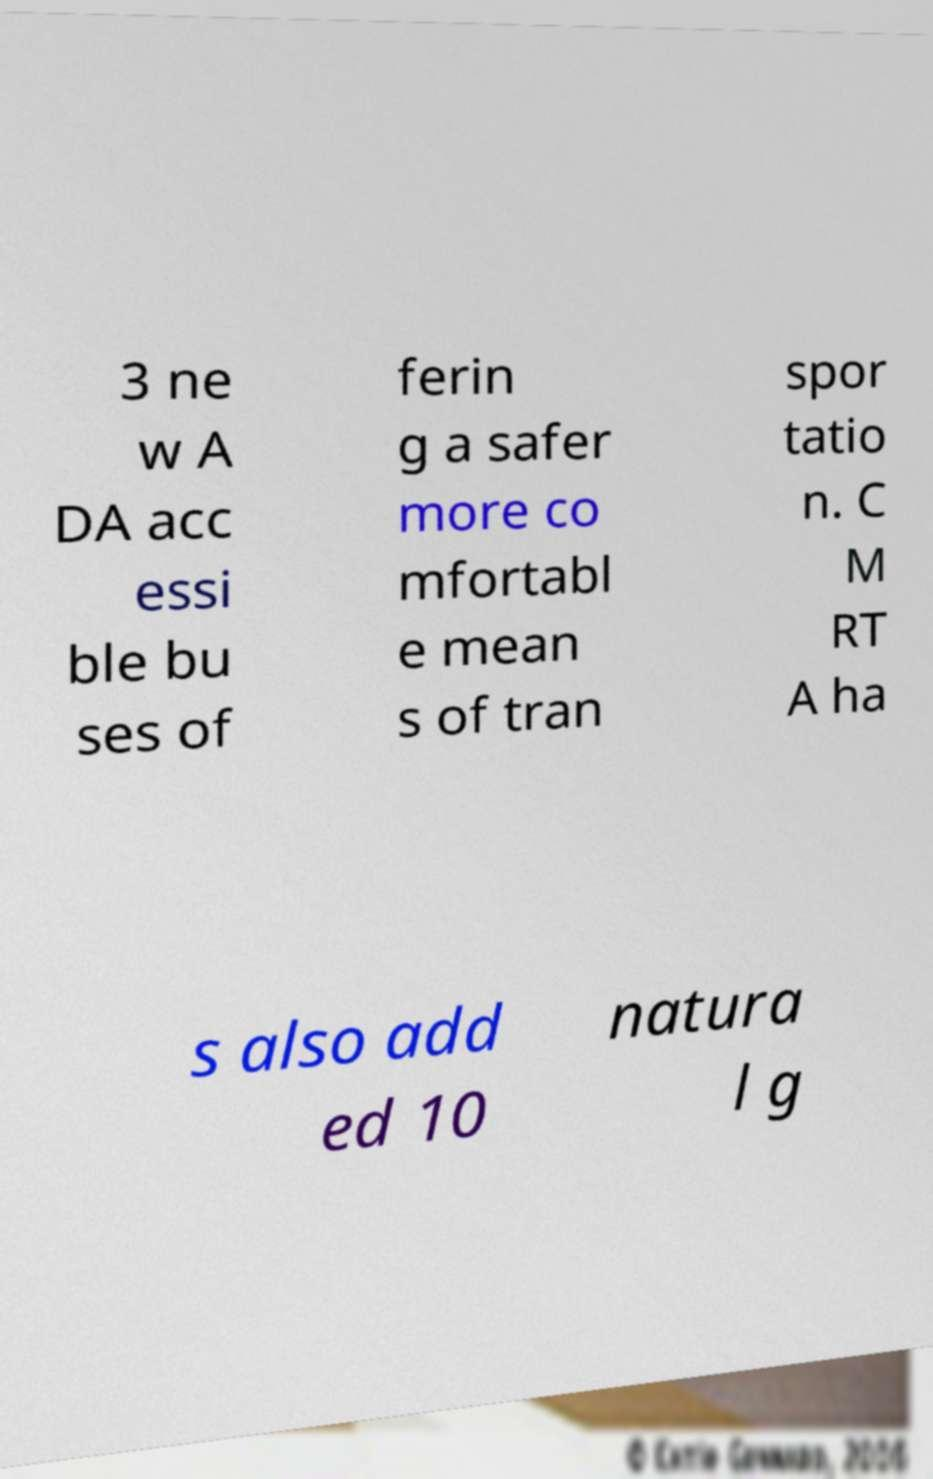Can you accurately transcribe the text from the provided image for me? 3 ne w A DA acc essi ble bu ses of ferin g a safer more co mfortabl e mean s of tran spor tatio n. C M RT A ha s also add ed 10 natura l g 